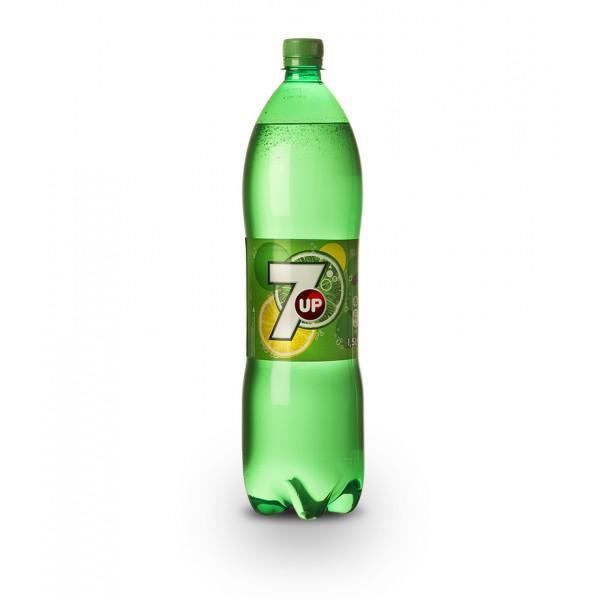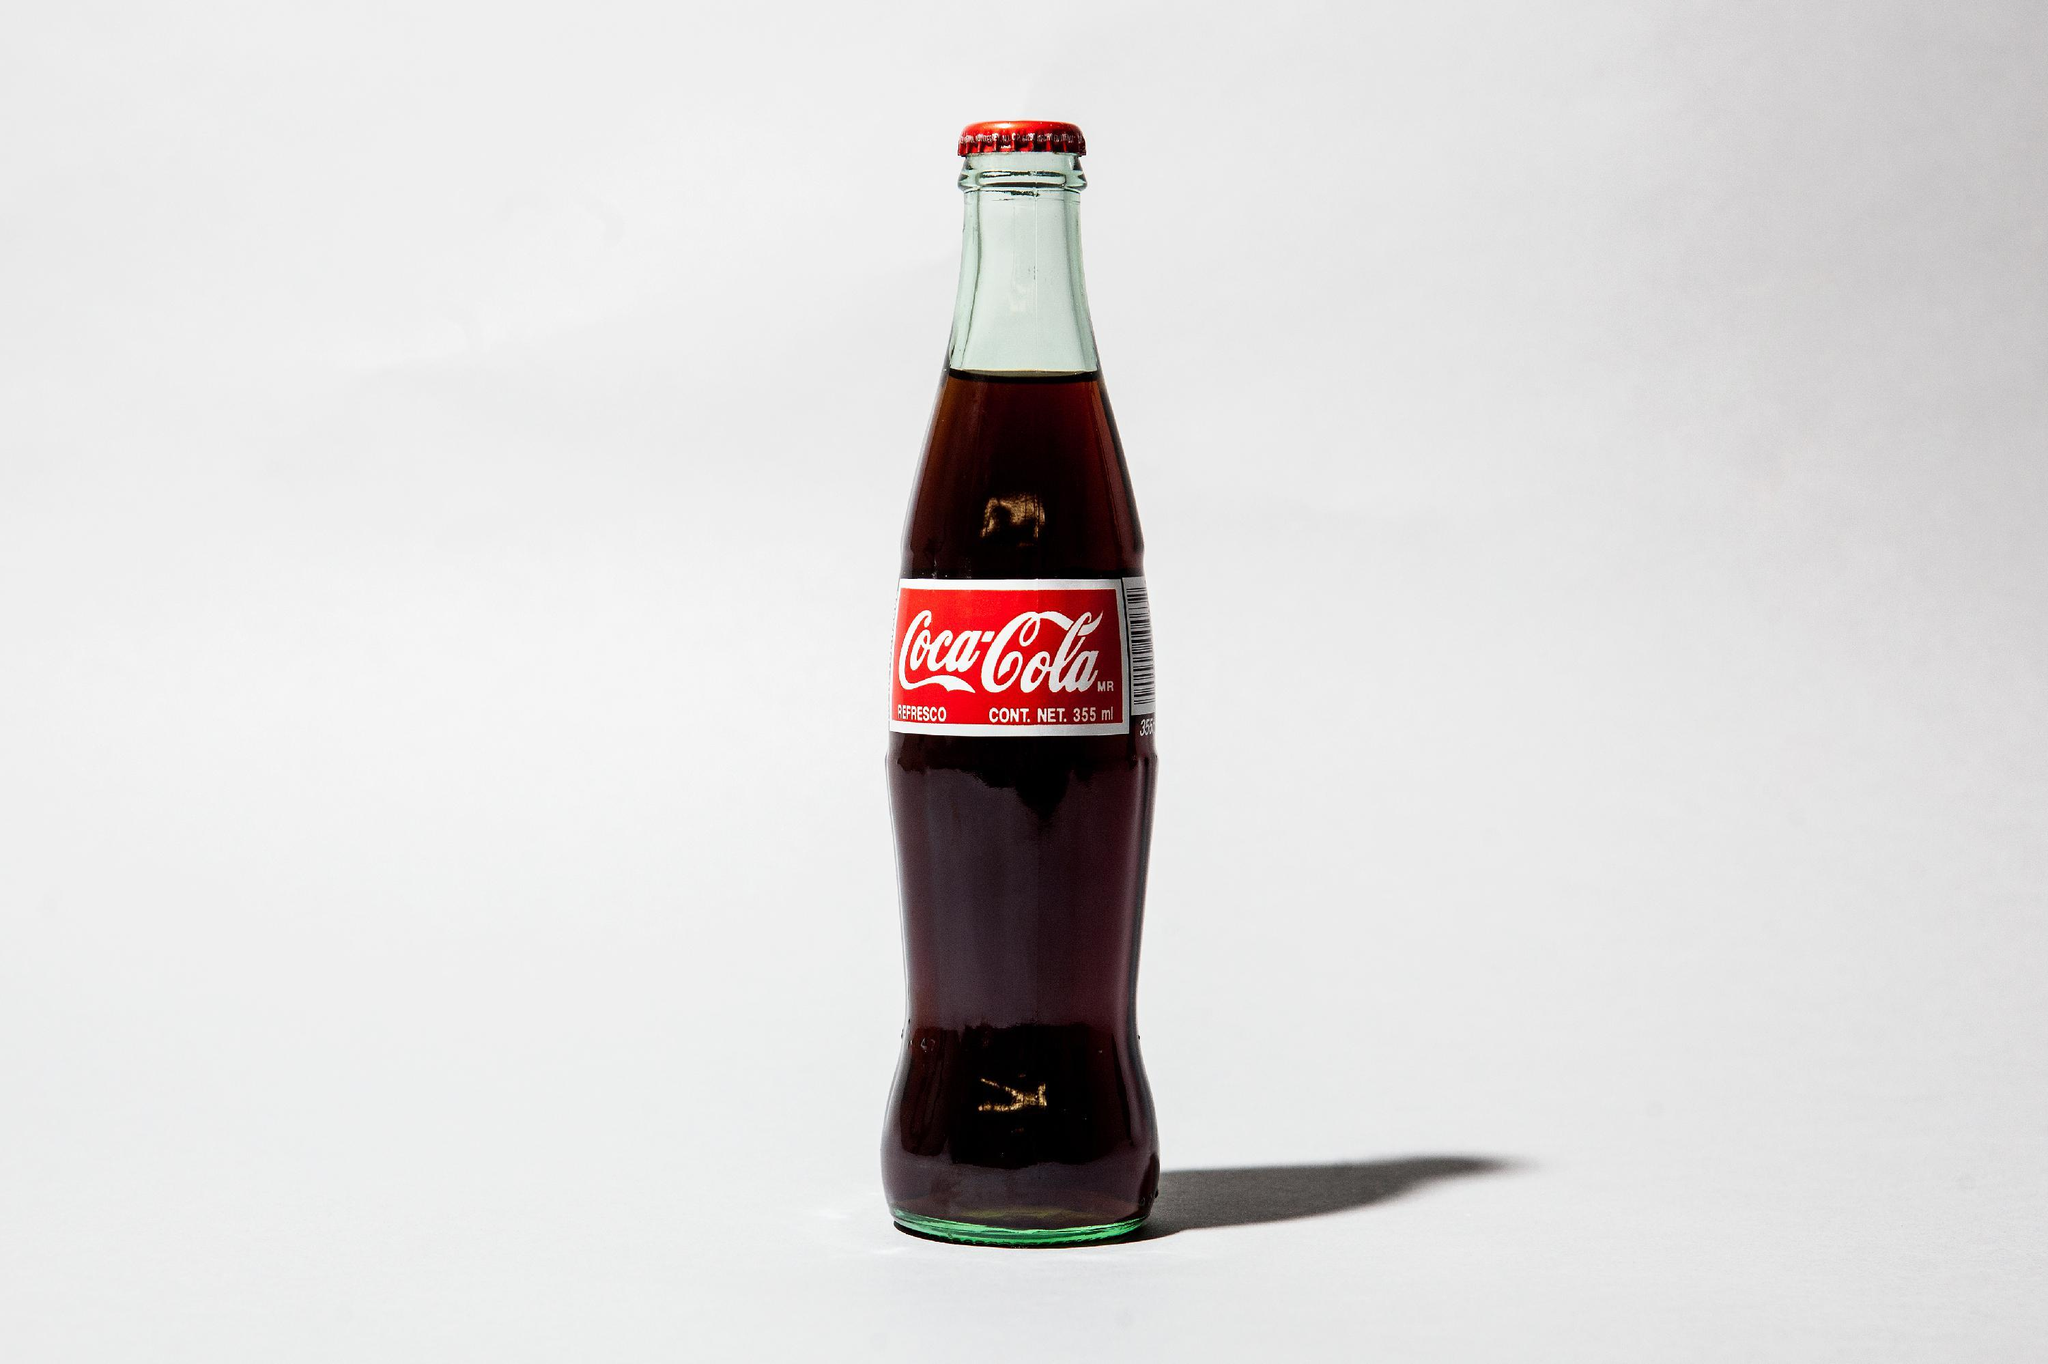The first image is the image on the left, the second image is the image on the right. Examine the images to the left and right. Is the description "There are two bottles, one glass and one plastic." accurate? Answer yes or no. Yes. The first image is the image on the left, the second image is the image on the right. Assess this claim about the two images: "The bottle in the image on the left has a white number on the label.". Correct or not? Answer yes or no. Yes. 